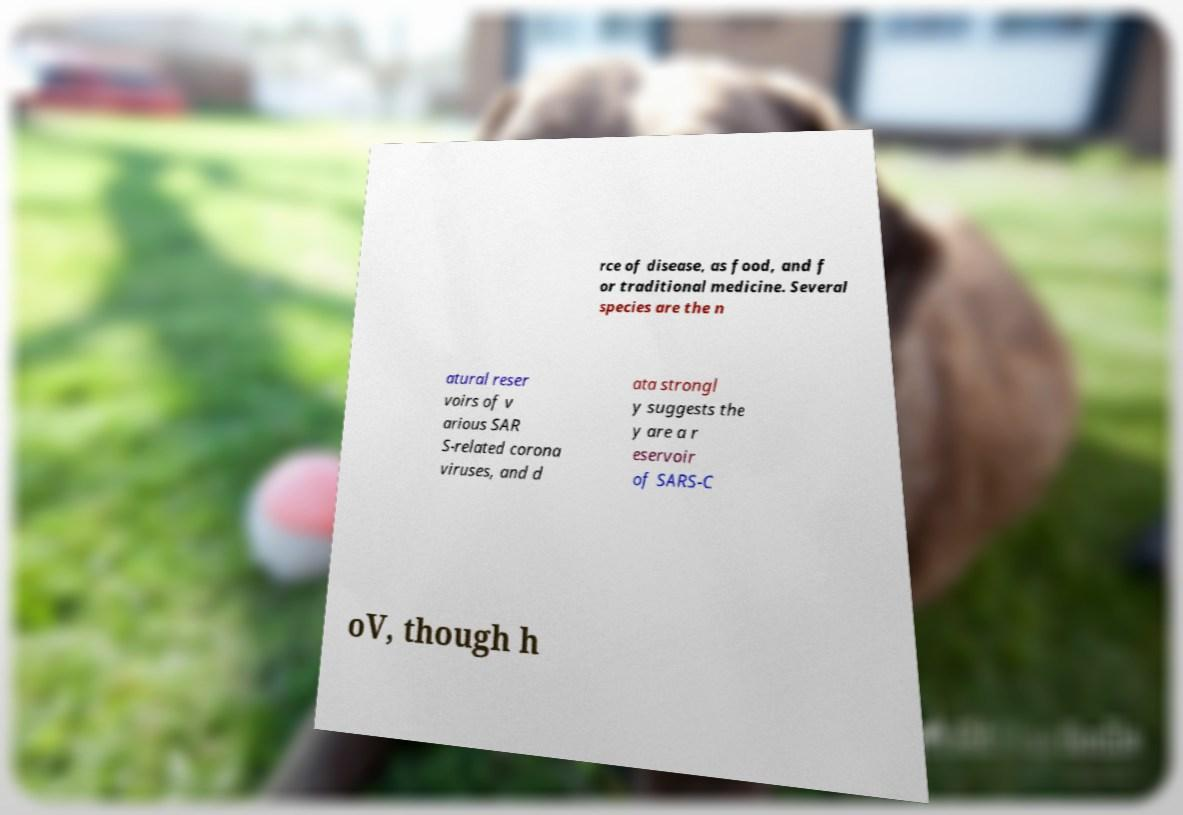Please identify and transcribe the text found in this image. rce of disease, as food, and f or traditional medicine. Several species are the n atural reser voirs of v arious SAR S-related corona viruses, and d ata strongl y suggests the y are a r eservoir of SARS-C oV, though h 